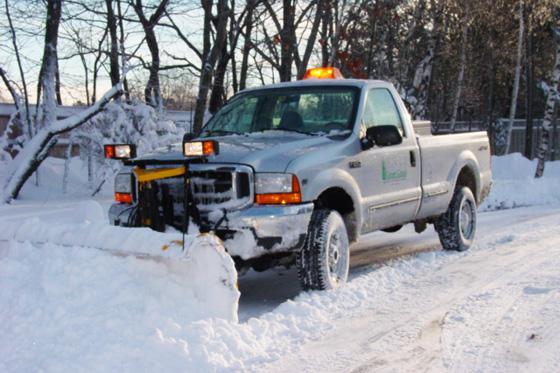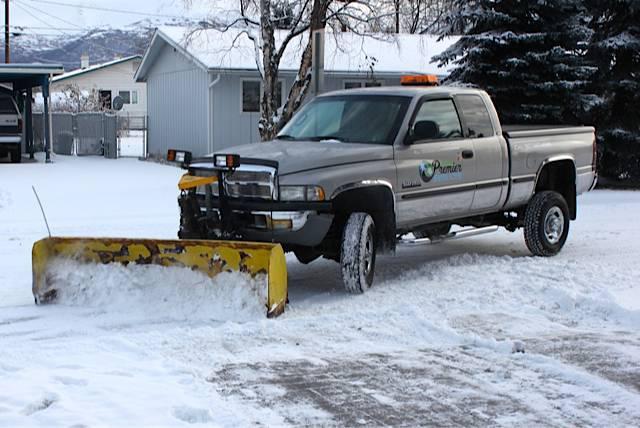The first image is the image on the left, the second image is the image on the right. Given the left and right images, does the statement "An orange truck has a plow on the front of it." hold true? Answer yes or no. No. The first image is the image on the left, the second image is the image on the right. For the images shown, is this caption "An image features a truck with an orange plow and orange cab." true? Answer yes or no. No. 